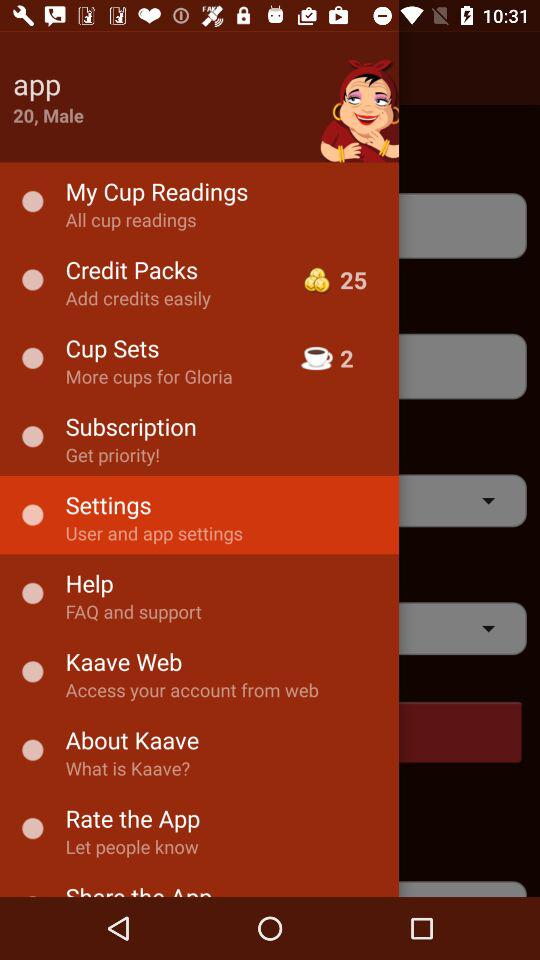What's the age of the person? The age of the person is 20 years. 